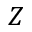<formula> <loc_0><loc_0><loc_500><loc_500>Z</formula> 